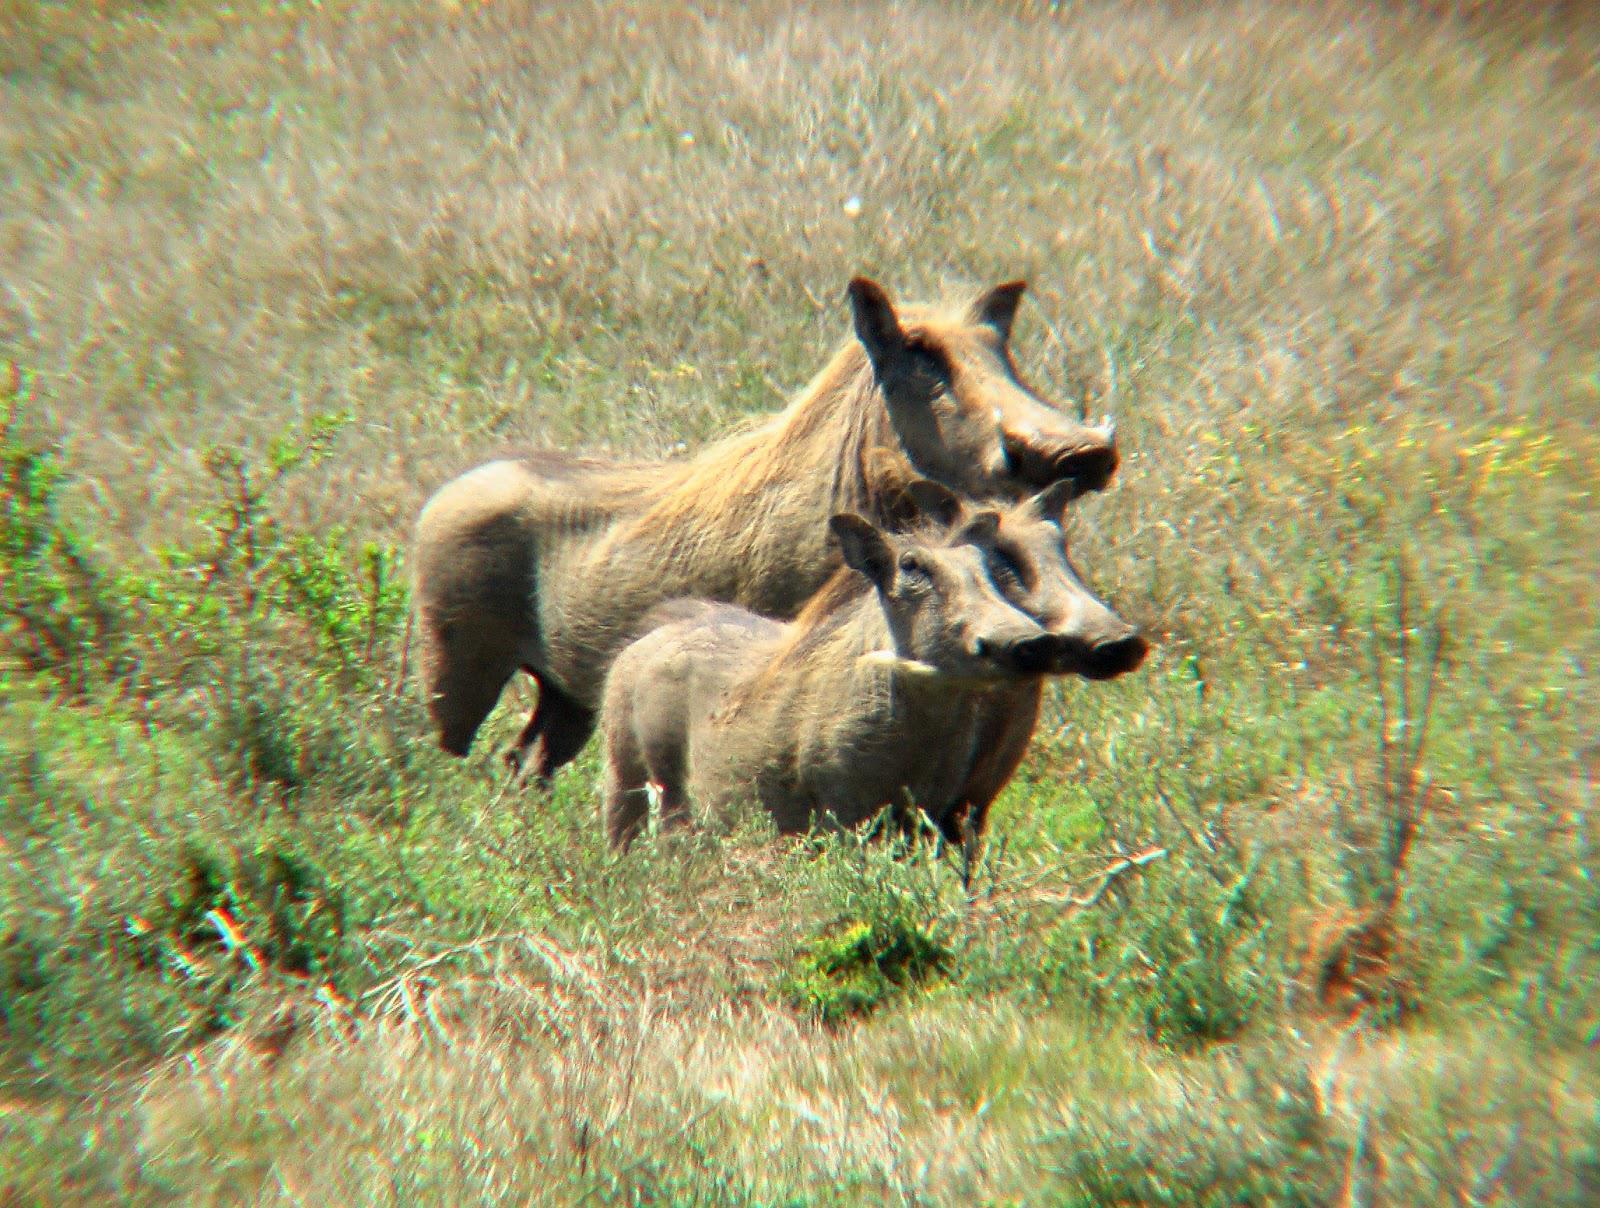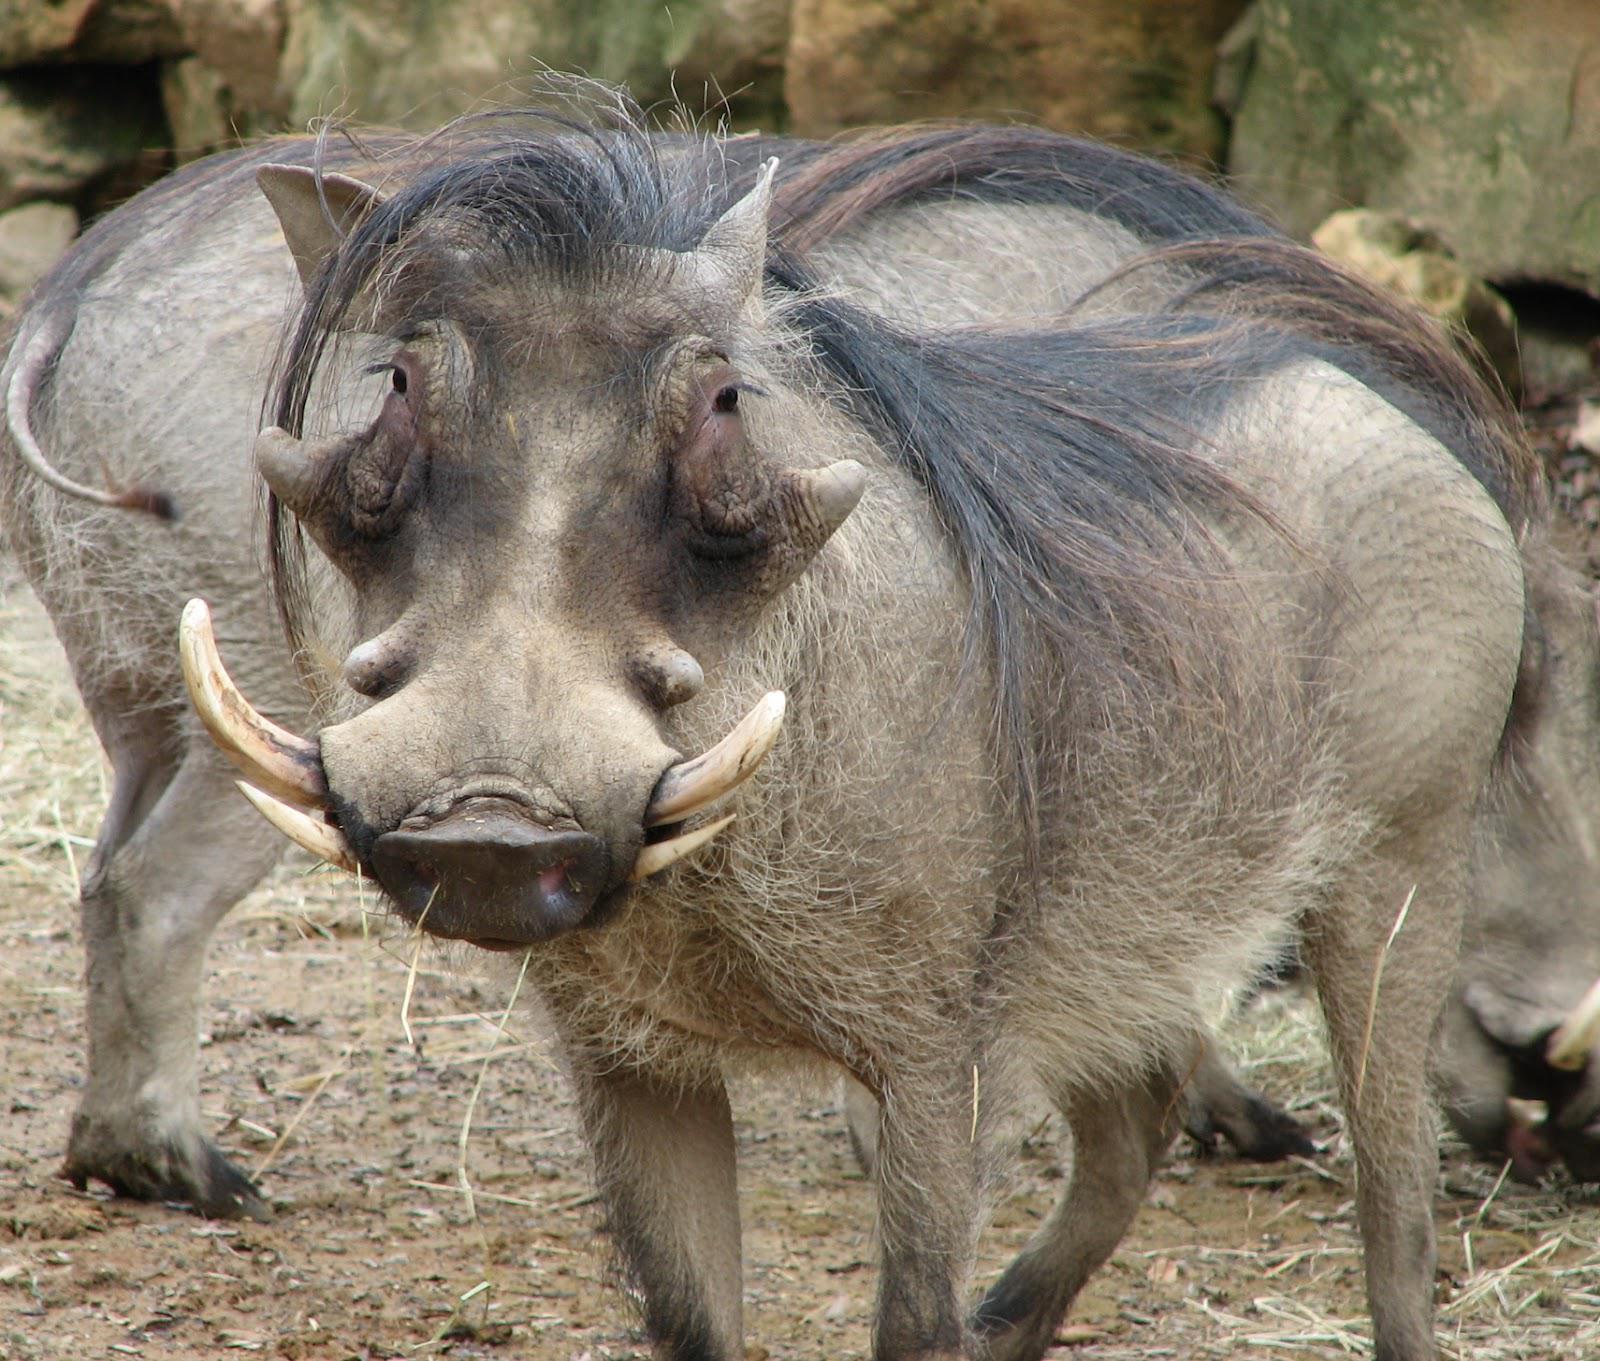The first image is the image on the left, the second image is the image on the right. Analyze the images presented: Is the assertion "Multiple warthogs stand at the edge of a muddy hole." valid? Answer yes or no. No. The first image is the image on the left, the second image is the image on the right. Considering the images on both sides, is "There is no more than one warthog in the left image." valid? Answer yes or no. No. 